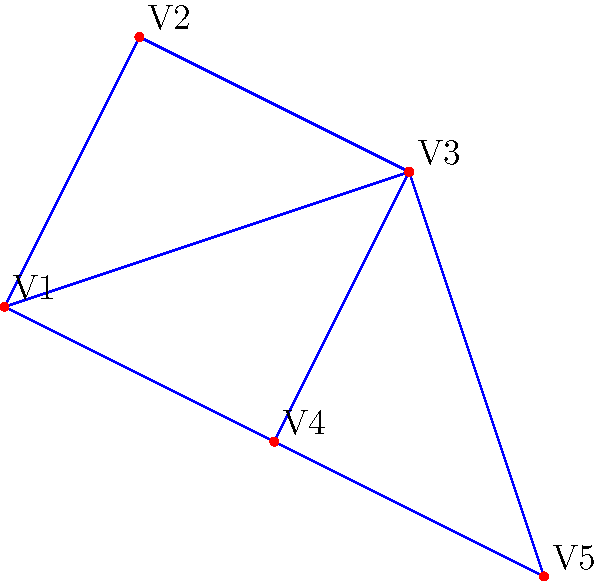Given the graph representing a sustainable transportation network connecting five conference venues (V1 to V5) in a city, what is the minimum number of routes that need to be established to ensure all venues are connected while minimizing infrastructure costs? To find the minimum number of routes needed to connect all venues while minimizing infrastructure costs, we need to determine the minimum spanning tree of the given graph. Here's a step-by-step explanation:

1. Recognize that this problem is equivalent to finding a minimum spanning tree in graph theory.

2. Count the number of vertices (conference venues) in the graph:
   There are 5 vertices (V1, V2, V3, V4, and V5).

3. Recall the property of minimum spanning trees:
   For a connected graph with $n$ vertices, the minimum spanning tree will have exactly $n-1$ edges.

4. Apply the formula:
   Number of routes = Number of vertices - 1
   Number of routes = $5 - 1 = 4$

5. Verify visually:
   We can see that removing any one edge from the current configuration would disconnect the graph, while adding any edge would create a cycle, which is unnecessary for connectivity.

Therefore, the minimum number of routes needed to connect all five venues while minimizing infrastructure costs is 4.
Answer: 4 routes 